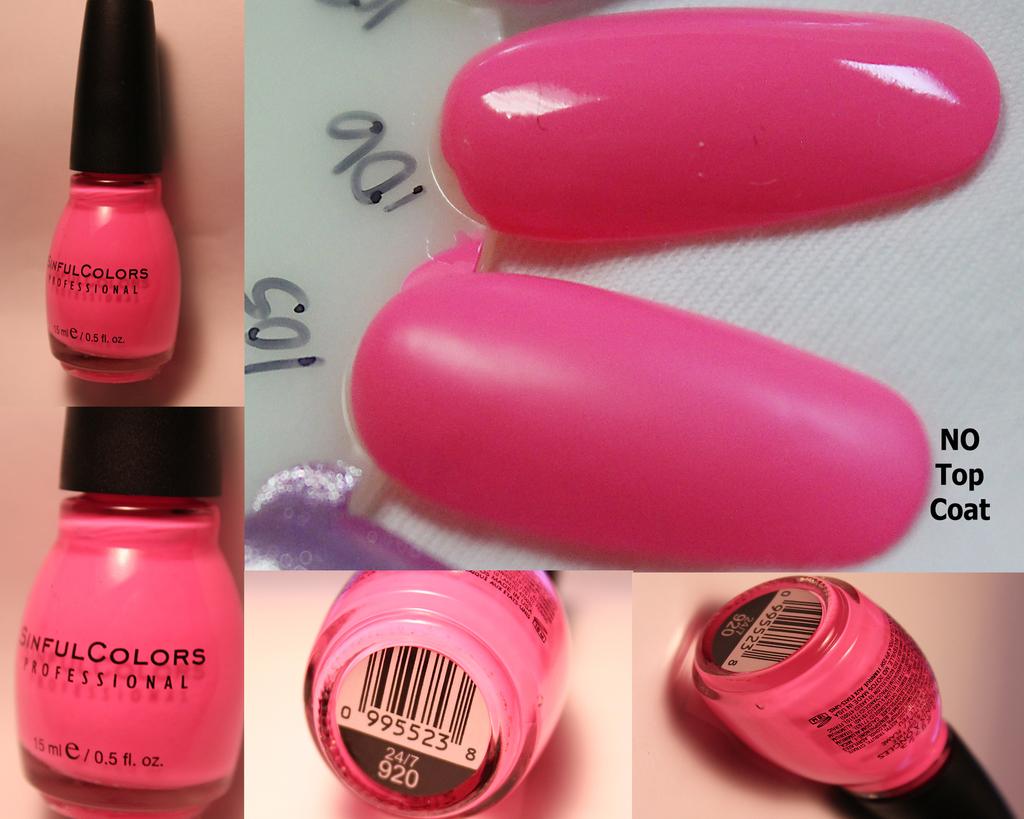What is the volume of this nail polish bottle?
Give a very brief answer. 0.5 fl oz. What brand is the nail polish?
Provide a short and direct response. Sinful colors. 